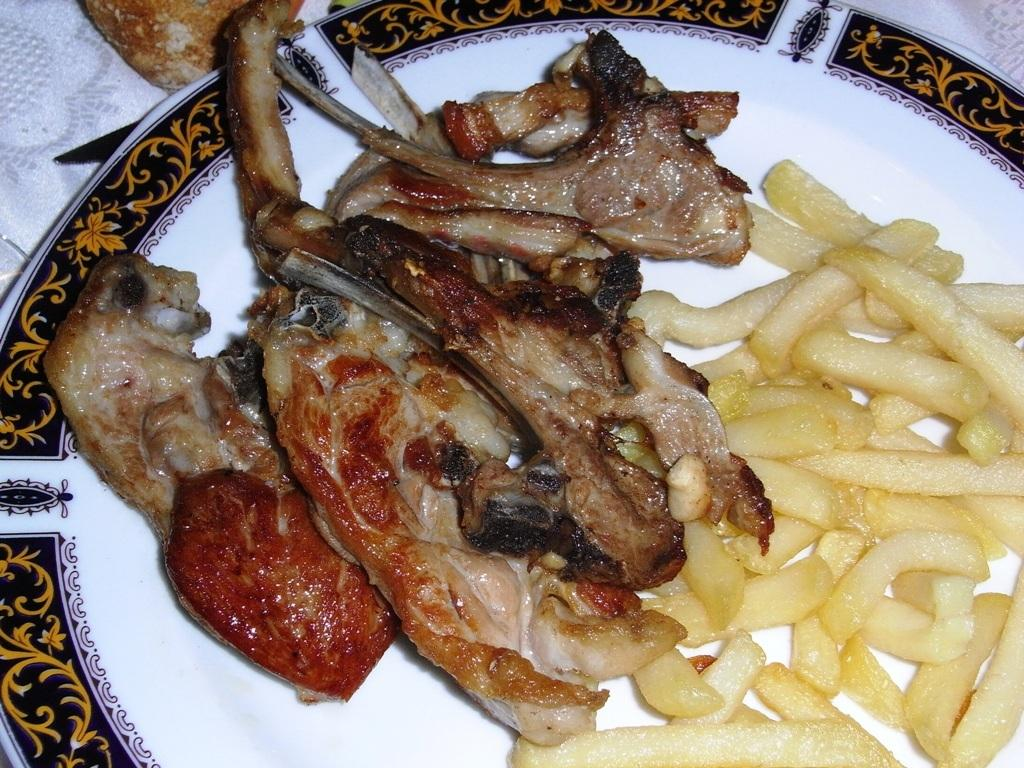What is on the plate that is visible in the image? The plate contains french fries and roasted meat. Where is the plate located in the image? The plate is placed on a table. Can you see the grandfather running towards the window in the image? There is no grandfather or window present in the image. 